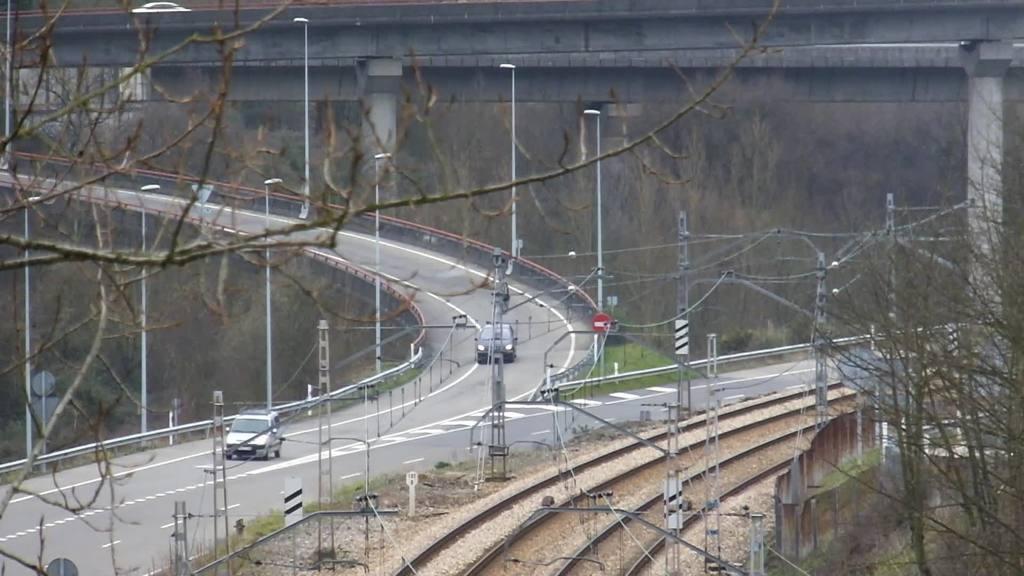Could you give a brief overview of what you see in this image? In the center of the image we can see two cars parked on the ground. In the foreground we can see a group of police, railway tracks. In the background, we can see a bridge, a group of trees and light poles. 